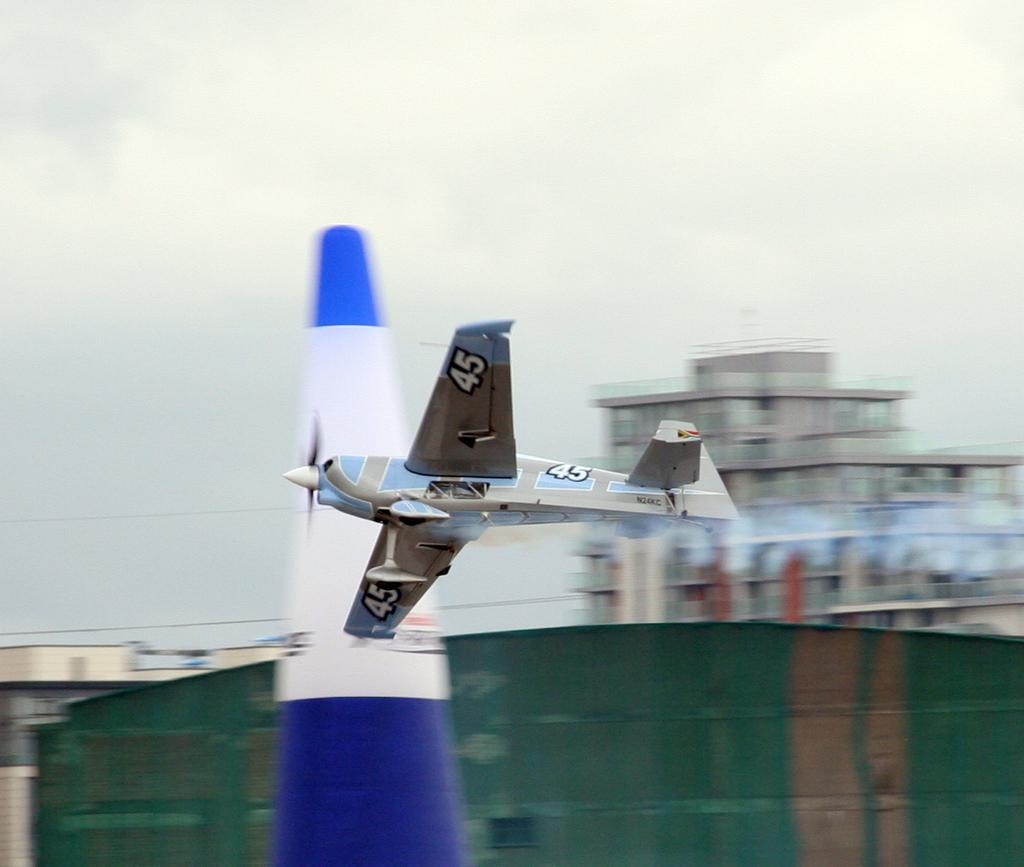Provide a one-sentence caption for the provided image. The small airplane has number 45 on its body and both wings. 